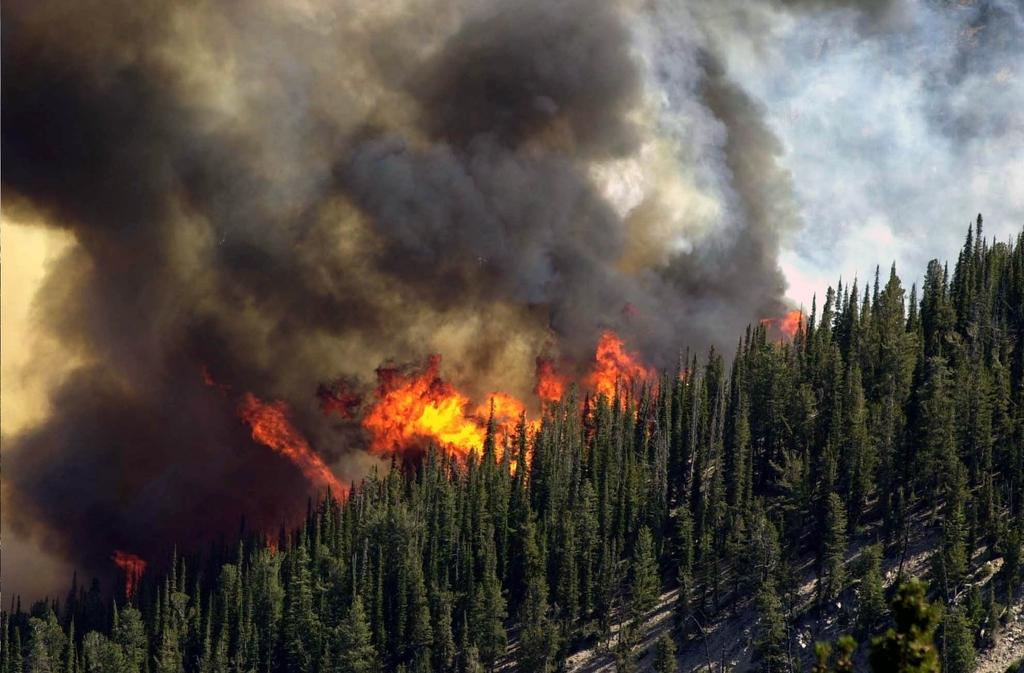What type of vegetation can be seen on the mountain in the image? There are trees on the mountain in the image. What is the source of the fire visible in the image? The facts provided do not specify the source of the fire. What is the result of the fire in the image? The result of the fire is visible smoke in the image. What type of plate is being used to serve the sun in the image? There is no plate or sun present in the image. Can you describe the clouds visible in the image? There are no clouds visible in the image; only trees, fire, and smoke are present. 